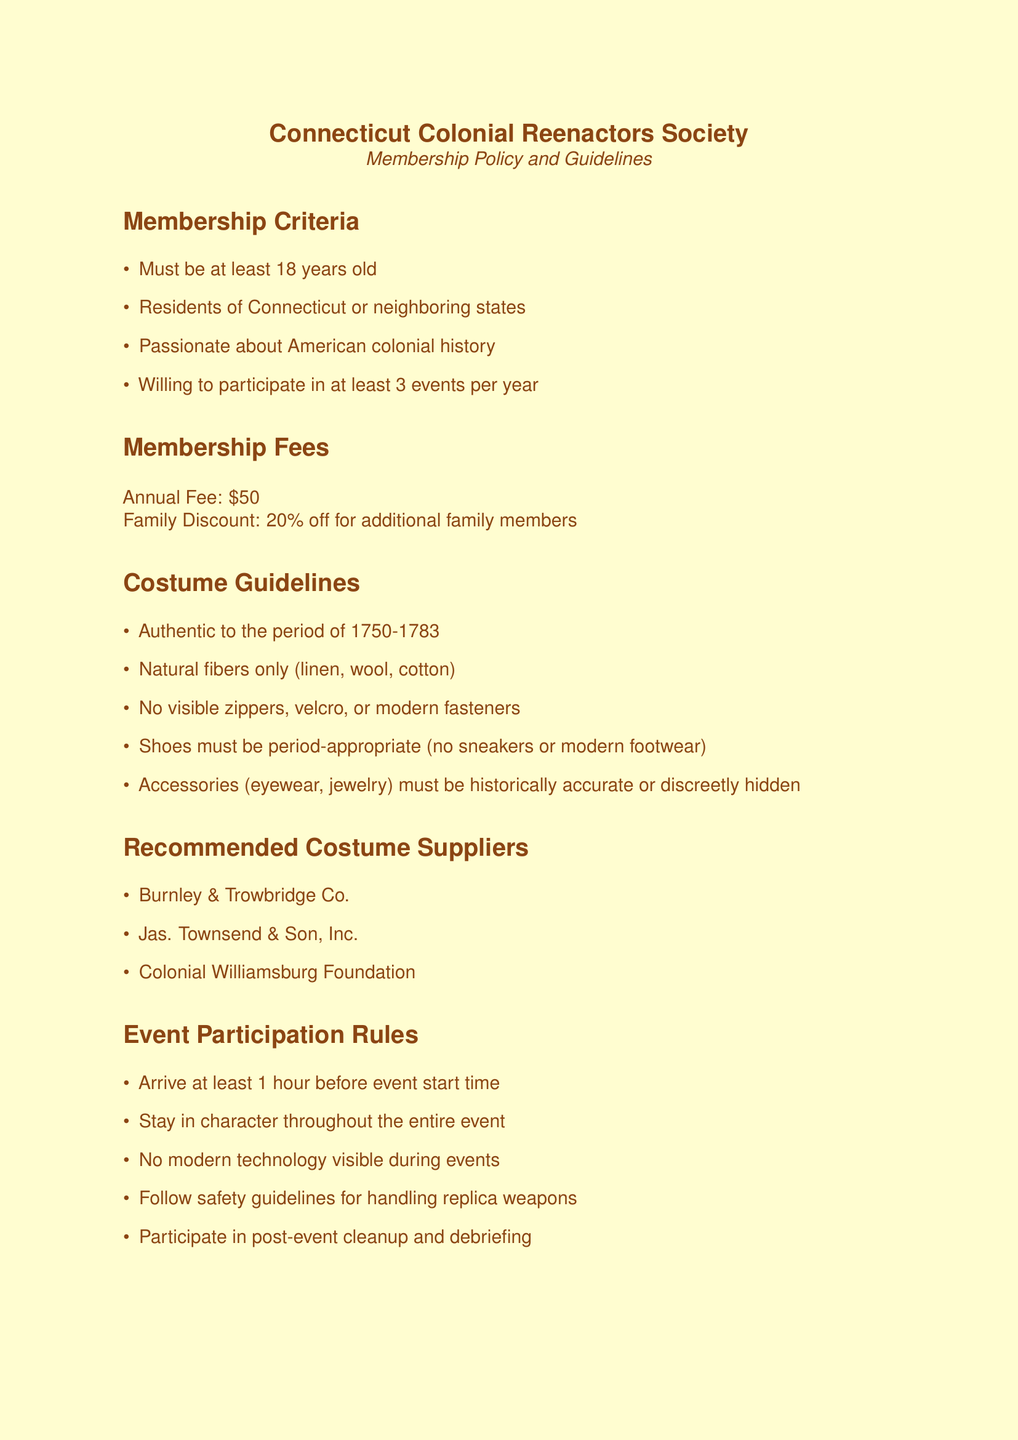What is the minimum age to join? The minimum age is specified in the membership criteria section of the document.
Answer: 18 years old What is the annual membership fee? The document outlines the membership fees, including the regular annual amount.
Answer: $50 What are the natural fibers allowed for costumes? The costume guidelines specify allowed materials by listing the types of fibers.
Answer: Linen, wool, cotton How many events must a member participate in annually? The membership criteria highlight the required number of events for members during a year.
Answer: 3 events What type of footwear is prohibited? The costume guidelines specify what type of shoes are not allowed during events.
Answer: Sneakers What is the first annual event listed? The annual events section enumerates specific events, starting with the first listed.
Answer: Battle of Ridgefield Reenactment What should members do during post-event activities? The event participation rules include a requirement for members after events.
Answer: Participate in cleanup What type of fasteners are not allowed in costumes? The costume guidelines mention what modern fasteners should not be visible on costumes.
Answer: Zippers, velcro, modern fasteners Which supplier is mentioned first in the recommended costume suppliers? The document lists recommended suppliers for costumes, specifying the order.
Answer: Burnley & Trowbridge Co 